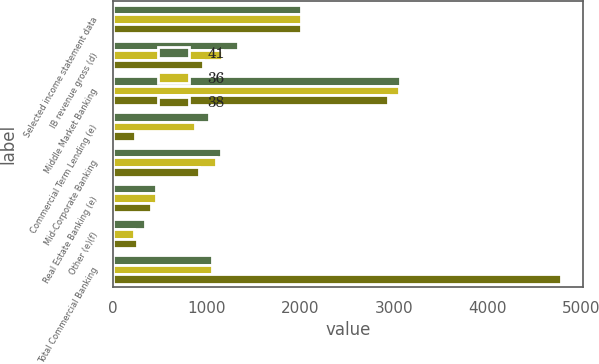<chart> <loc_0><loc_0><loc_500><loc_500><stacked_bar_chart><ecel><fcel>Selected income statement data<fcel>IB revenue gross (d)<fcel>Middle Market Banking<fcel>Commercial Term Lending (e)<fcel>Mid-Corporate Banking<fcel>Real Estate Banking (e)<fcel>Other (e)(f)<fcel>Total Commercial Banking<nl><fcel>41<fcel>2010<fcel>1335<fcel>3060<fcel>1023<fcel>1154<fcel>460<fcel>343<fcel>1062.5<nl><fcel>36<fcel>2009<fcel>1163<fcel>3055<fcel>875<fcel>1102<fcel>461<fcel>227<fcel>1062.5<nl><fcel>38<fcel>2008<fcel>966<fcel>2939<fcel>243<fcel>921<fcel>413<fcel>261<fcel>4777<nl></chart> 